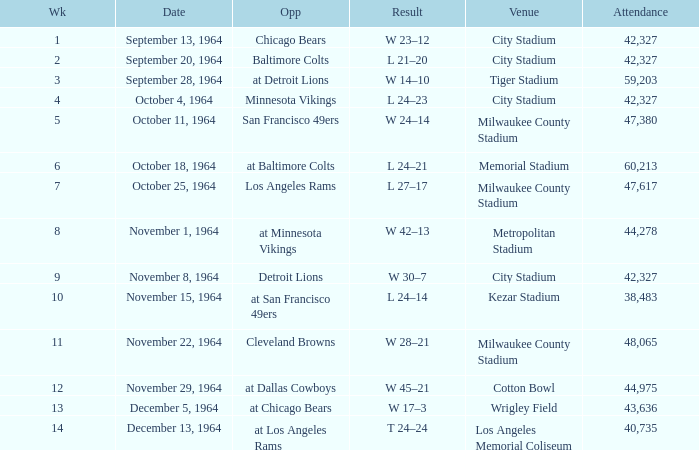What is the average week of the game on November 22, 1964 attended by 48,065? None. 